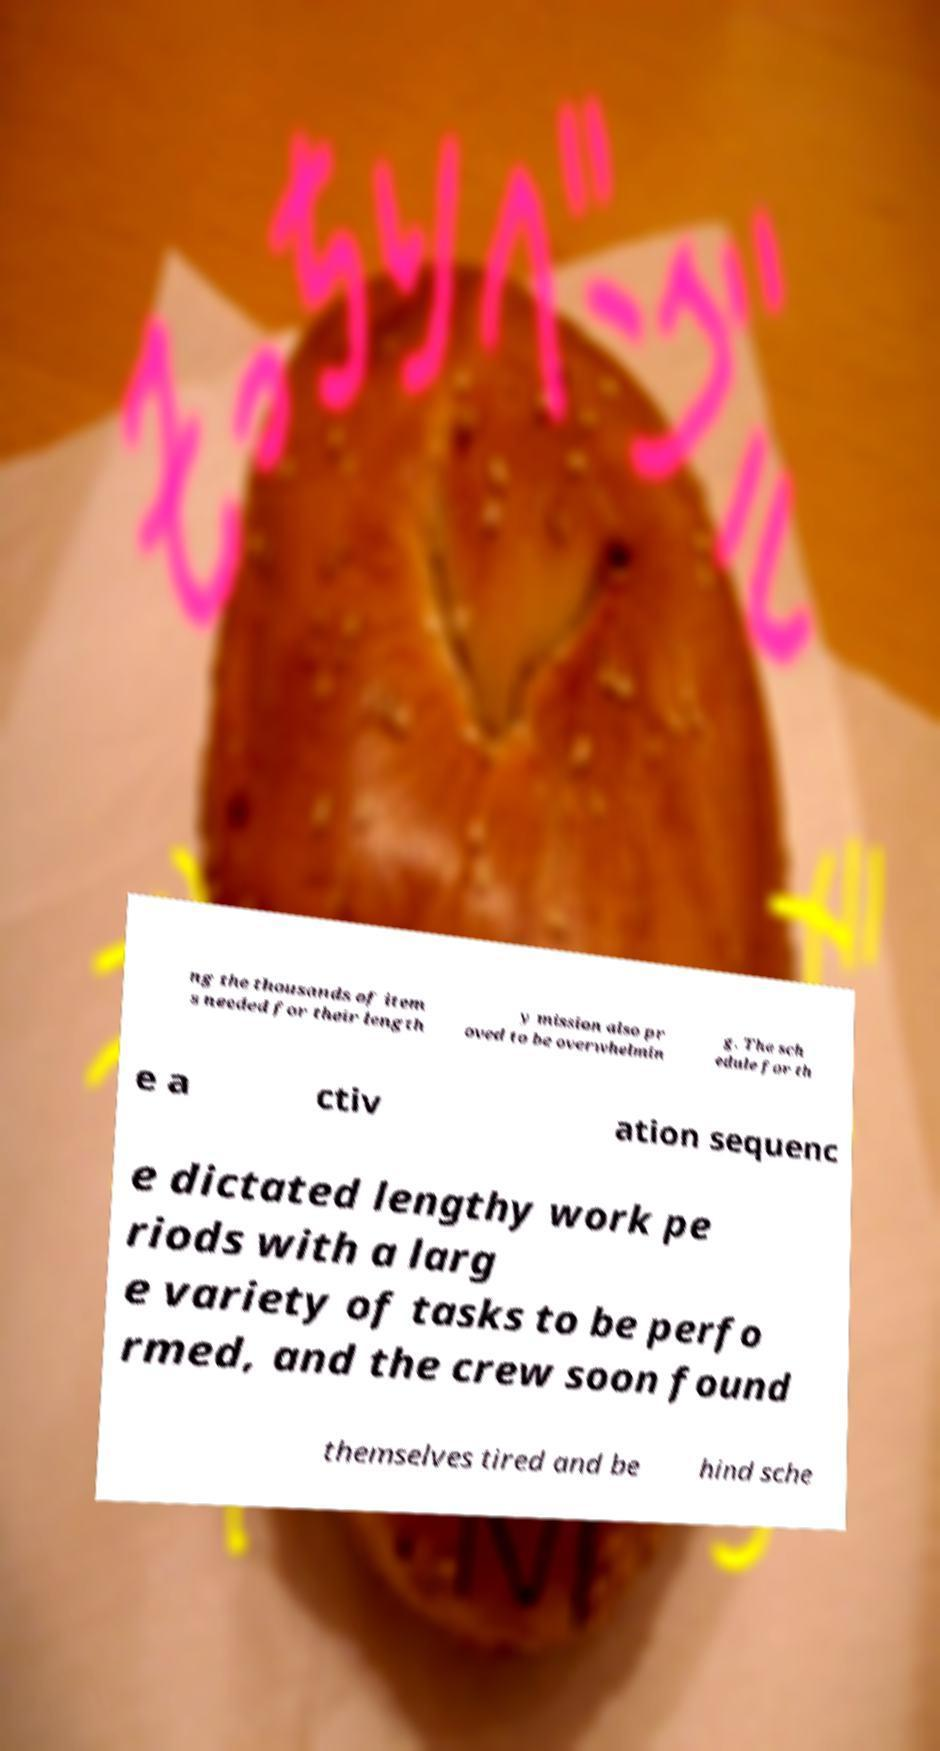For documentation purposes, I need the text within this image transcribed. Could you provide that? ng the thousands of item s needed for their length y mission also pr oved to be overwhelmin g. The sch edule for th e a ctiv ation sequenc e dictated lengthy work pe riods with a larg e variety of tasks to be perfo rmed, and the crew soon found themselves tired and be hind sche 